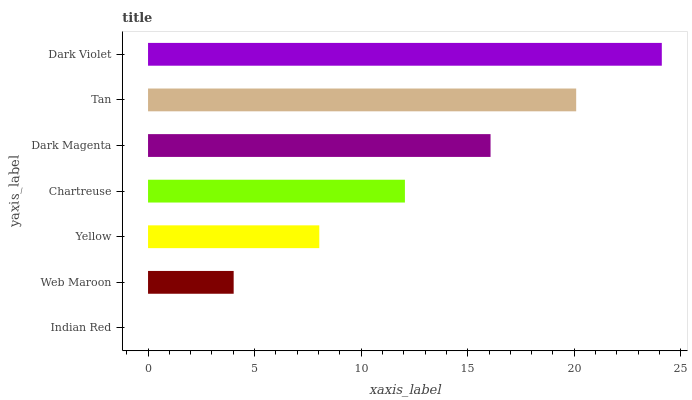Is Indian Red the minimum?
Answer yes or no. Yes. Is Dark Violet the maximum?
Answer yes or no. Yes. Is Web Maroon the minimum?
Answer yes or no. No. Is Web Maroon the maximum?
Answer yes or no. No. Is Web Maroon greater than Indian Red?
Answer yes or no. Yes. Is Indian Red less than Web Maroon?
Answer yes or no. Yes. Is Indian Red greater than Web Maroon?
Answer yes or no. No. Is Web Maroon less than Indian Red?
Answer yes or no. No. Is Chartreuse the high median?
Answer yes or no. Yes. Is Chartreuse the low median?
Answer yes or no. Yes. Is Dark Violet the high median?
Answer yes or no. No. Is Tan the low median?
Answer yes or no. No. 